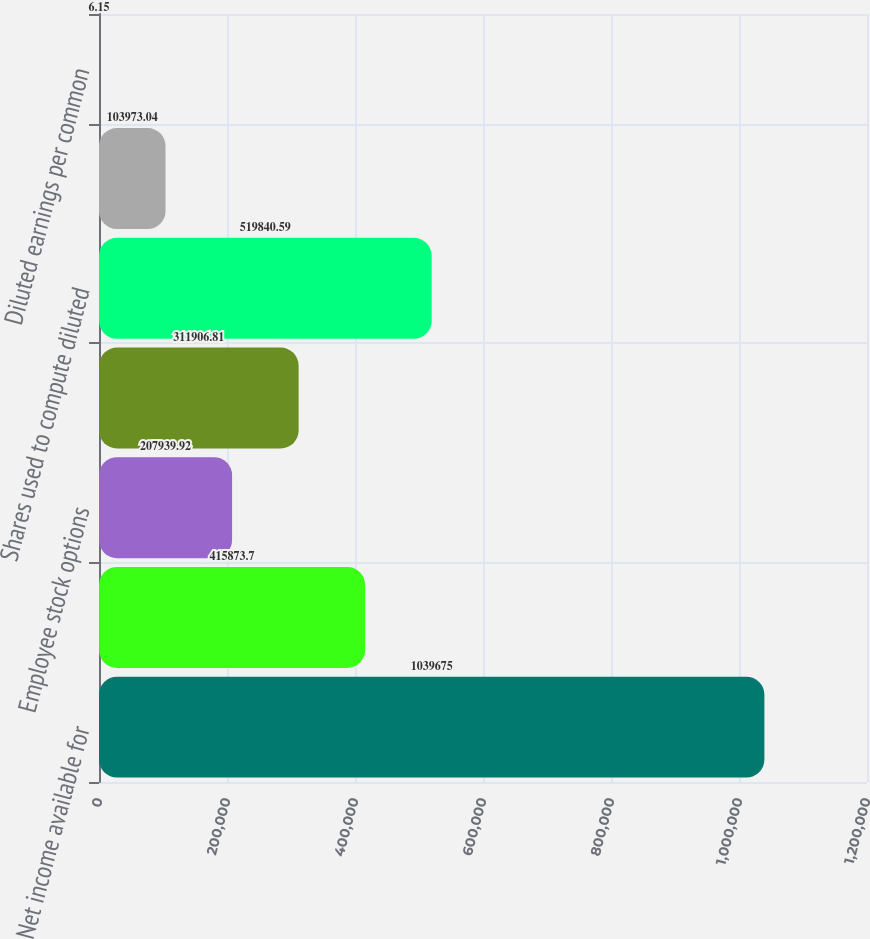Convert chart to OTSL. <chart><loc_0><loc_0><loc_500><loc_500><bar_chart><fcel>Net income available for<fcel>Weighted-average outstanding<fcel>Employee stock options<fcel>Restricted stock awards<fcel>Shares used to compute diluted<fcel>Basic earnings per common<fcel>Diluted earnings per common<nl><fcel>1.03968e+06<fcel>415874<fcel>207940<fcel>311907<fcel>519841<fcel>103973<fcel>6.15<nl></chart> 